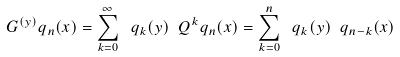Convert formula to latex. <formula><loc_0><loc_0><loc_500><loc_500>G ^ { ( y ) } q _ { n } ( x ) = \sum _ { k = 0 } ^ { \infty } \ q _ { k } ( y ) \ Q ^ { k } q _ { n } ( x ) = \sum _ { k = 0 } ^ { n } \ q _ { k } ( y ) \ q _ { n - k } ( x )</formula> 